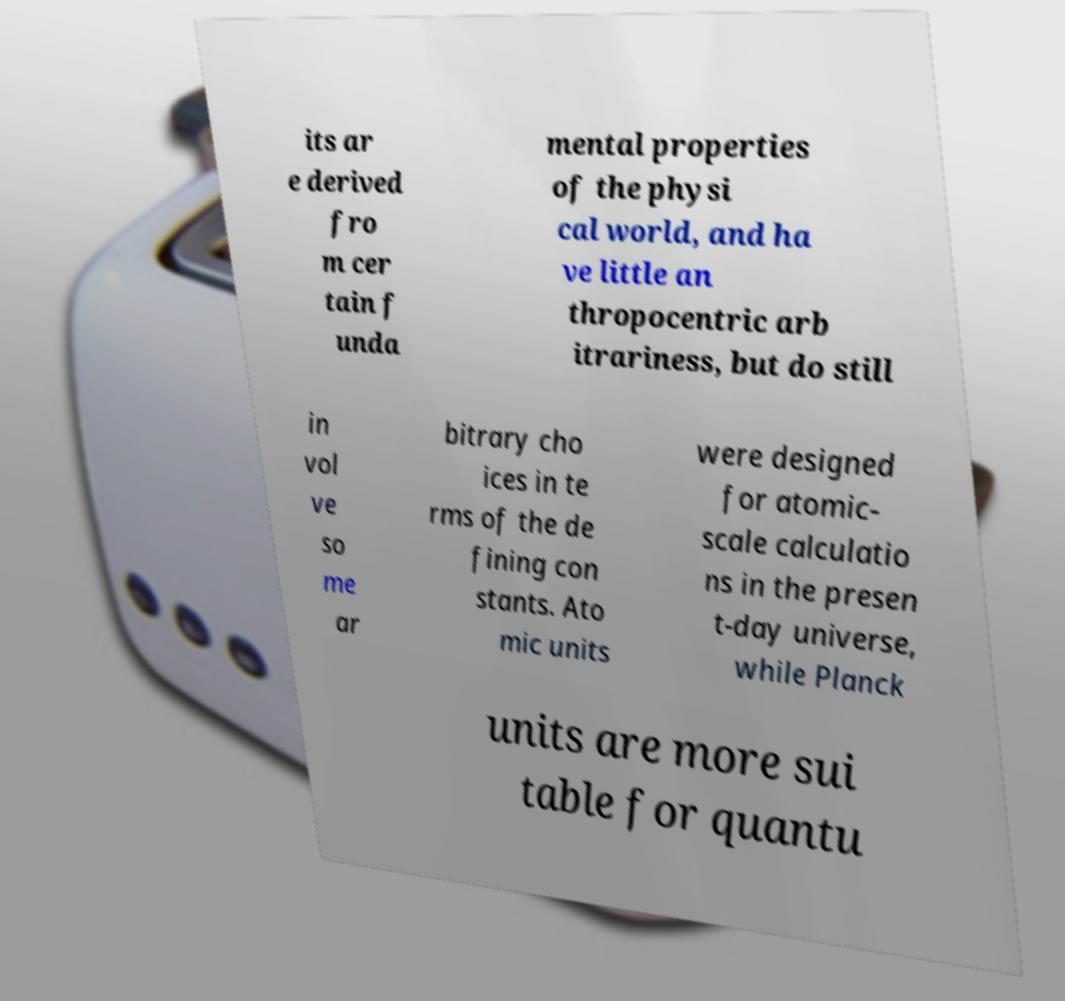For documentation purposes, I need the text within this image transcribed. Could you provide that? its ar e derived fro m cer tain f unda mental properties of the physi cal world, and ha ve little an thropocentric arb itrariness, but do still in vol ve so me ar bitrary cho ices in te rms of the de fining con stants. Ato mic units were designed for atomic- scale calculatio ns in the presen t-day universe, while Planck units are more sui table for quantu 